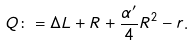<formula> <loc_0><loc_0><loc_500><loc_500>Q \colon = \Delta L + R + \frac { \alpha ^ { \prime } } { 4 } R ^ { 2 } - r .</formula> 